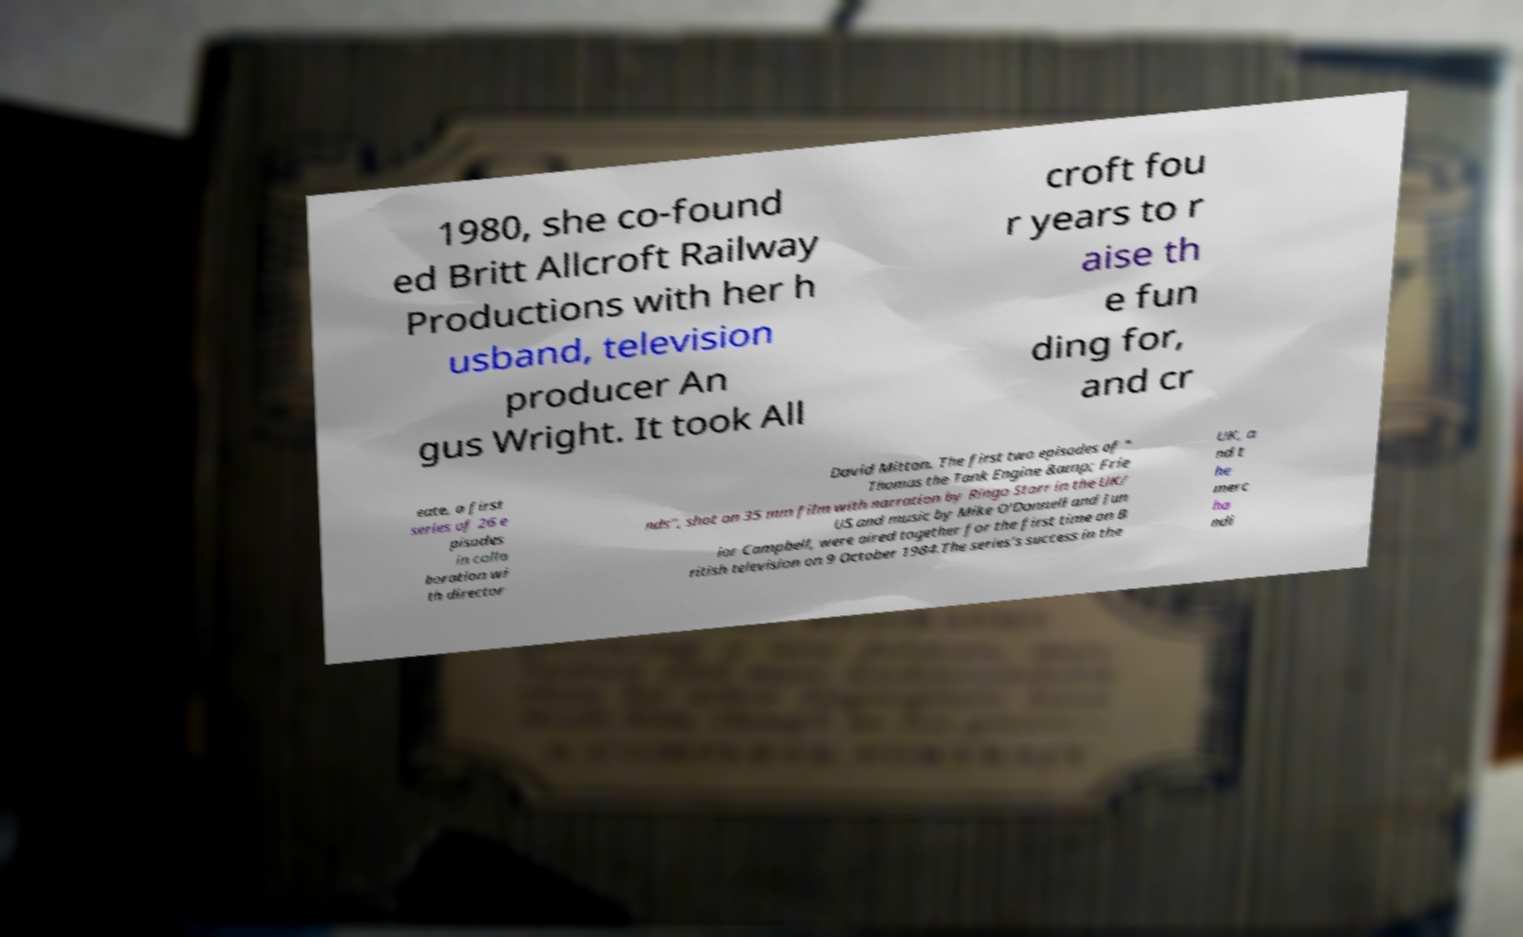Can you accurately transcribe the text from the provided image for me? 1980, she co-found ed Britt Allcroft Railway Productions with her h usband, television producer An gus Wright. It took All croft fou r years to r aise th e fun ding for, and cr eate, a first series of 26 e pisodes in colla boration wi th director David Mitton. The first two episodes of " Thomas the Tank Engine &amp; Frie nds", shot on 35 mm film with narration by Ringo Starr in the UK/ US and music by Mike O'Donnell and Jun ior Campbell, were aired together for the first time on B ritish television on 9 October 1984.The series's success in the UK, a nd t he merc ha ndi 